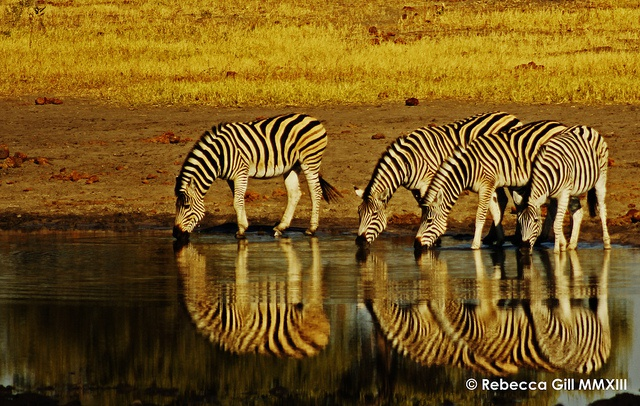Describe the objects in this image and their specific colors. I can see zebra in olive, black, khaki, and maroon tones, zebra in olive, khaki, black, and maroon tones, zebra in olive, black, maroon, and khaki tones, and zebra in olive, black, khaki, and maroon tones in this image. 